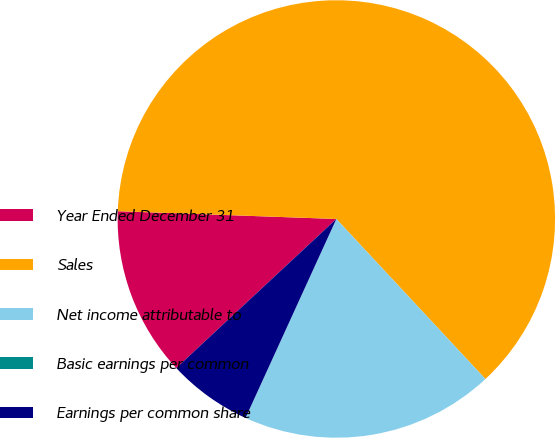<chart> <loc_0><loc_0><loc_500><loc_500><pie_chart><fcel>Year Ended December 31<fcel>Sales<fcel>Net income attributable to<fcel>Basic earnings per common<fcel>Earnings per common share<nl><fcel>12.5%<fcel>62.5%<fcel>18.75%<fcel>0.0%<fcel>6.25%<nl></chart> 